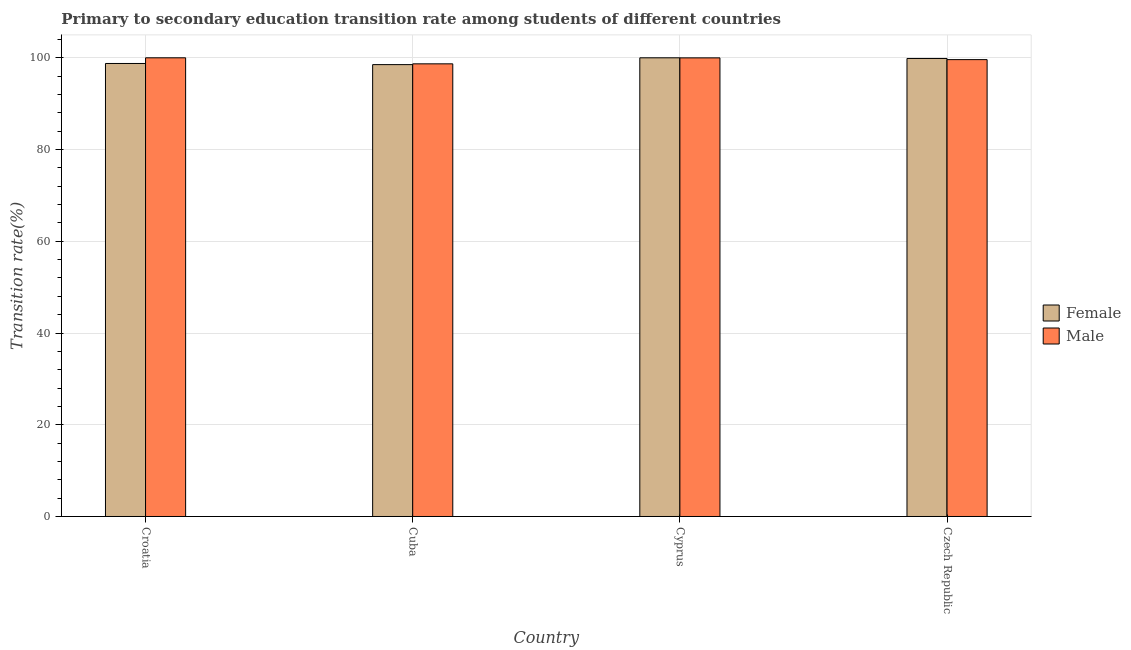How many groups of bars are there?
Your answer should be very brief. 4. Are the number of bars on each tick of the X-axis equal?
Give a very brief answer. Yes. How many bars are there on the 3rd tick from the left?
Your answer should be compact. 2. What is the label of the 3rd group of bars from the left?
Provide a short and direct response. Cyprus. What is the transition rate among female students in Cuba?
Offer a terse response. 98.52. Across all countries, what is the maximum transition rate among male students?
Make the answer very short. 100. Across all countries, what is the minimum transition rate among male students?
Your answer should be compact. 98.69. In which country was the transition rate among female students maximum?
Give a very brief answer. Cyprus. In which country was the transition rate among female students minimum?
Your answer should be compact. Cuba. What is the total transition rate among male students in the graph?
Provide a succinct answer. 398.28. What is the difference between the transition rate among male students in Croatia and that in Czech Republic?
Your answer should be compact. 0.39. What is the difference between the transition rate among male students in Croatia and the transition rate among female students in Czech Republic?
Your answer should be very brief. 0.15. What is the average transition rate among male students per country?
Your response must be concise. 99.57. What is the difference between the transition rate among male students and transition rate among female students in Cyprus?
Your answer should be compact. -0.01. In how many countries, is the transition rate among female students greater than 80 %?
Your response must be concise. 4. What is the ratio of the transition rate among male students in Croatia to that in Cyprus?
Give a very brief answer. 1. What is the difference between the highest and the second highest transition rate among female students?
Provide a short and direct response. 0.15. What is the difference between the highest and the lowest transition rate among female students?
Your answer should be very brief. 1.48. What does the 2nd bar from the left in Czech Republic represents?
Your response must be concise. Male. What does the 1st bar from the right in Cuba represents?
Your response must be concise. Male. How many bars are there?
Your answer should be very brief. 8. Are the values on the major ticks of Y-axis written in scientific E-notation?
Your answer should be compact. No. Does the graph contain any zero values?
Provide a short and direct response. No. What is the title of the graph?
Offer a terse response. Primary to secondary education transition rate among students of different countries. What is the label or title of the Y-axis?
Ensure brevity in your answer.  Transition rate(%). What is the Transition rate(%) in Female in Croatia?
Make the answer very short. 98.77. What is the Transition rate(%) of Male in Croatia?
Ensure brevity in your answer.  100. What is the Transition rate(%) of Female in Cuba?
Make the answer very short. 98.52. What is the Transition rate(%) of Male in Cuba?
Ensure brevity in your answer.  98.69. What is the Transition rate(%) in Male in Cyprus?
Provide a succinct answer. 99.99. What is the Transition rate(%) of Female in Czech Republic?
Your answer should be compact. 99.85. What is the Transition rate(%) in Male in Czech Republic?
Provide a short and direct response. 99.61. Across all countries, what is the maximum Transition rate(%) in Male?
Ensure brevity in your answer.  100. Across all countries, what is the minimum Transition rate(%) in Female?
Your answer should be very brief. 98.52. Across all countries, what is the minimum Transition rate(%) in Male?
Your answer should be compact. 98.69. What is the total Transition rate(%) of Female in the graph?
Keep it short and to the point. 397.13. What is the total Transition rate(%) in Male in the graph?
Provide a succinct answer. 398.28. What is the difference between the Transition rate(%) in Female in Croatia and that in Cuba?
Keep it short and to the point. 0.25. What is the difference between the Transition rate(%) of Male in Croatia and that in Cuba?
Give a very brief answer. 1.31. What is the difference between the Transition rate(%) of Female in Croatia and that in Cyprus?
Keep it short and to the point. -1.24. What is the difference between the Transition rate(%) of Male in Croatia and that in Cyprus?
Offer a very short reply. 0.01. What is the difference between the Transition rate(%) in Female in Croatia and that in Czech Republic?
Make the answer very short. -1.09. What is the difference between the Transition rate(%) of Male in Croatia and that in Czech Republic?
Make the answer very short. 0.39. What is the difference between the Transition rate(%) in Female in Cuba and that in Cyprus?
Make the answer very short. -1.48. What is the difference between the Transition rate(%) in Male in Cuba and that in Cyprus?
Your response must be concise. -1.3. What is the difference between the Transition rate(%) in Female in Cuba and that in Czech Republic?
Make the answer very short. -1.34. What is the difference between the Transition rate(%) in Male in Cuba and that in Czech Republic?
Provide a succinct answer. -0.92. What is the difference between the Transition rate(%) in Female in Cyprus and that in Czech Republic?
Make the answer very short. 0.15. What is the difference between the Transition rate(%) in Male in Cyprus and that in Czech Republic?
Your answer should be very brief. 0.38. What is the difference between the Transition rate(%) of Female in Croatia and the Transition rate(%) of Male in Cuba?
Provide a short and direct response. 0.08. What is the difference between the Transition rate(%) in Female in Croatia and the Transition rate(%) in Male in Cyprus?
Offer a very short reply. -1.22. What is the difference between the Transition rate(%) in Female in Croatia and the Transition rate(%) in Male in Czech Republic?
Provide a short and direct response. -0.84. What is the difference between the Transition rate(%) of Female in Cuba and the Transition rate(%) of Male in Cyprus?
Provide a short and direct response. -1.47. What is the difference between the Transition rate(%) of Female in Cuba and the Transition rate(%) of Male in Czech Republic?
Ensure brevity in your answer.  -1.09. What is the difference between the Transition rate(%) in Female in Cyprus and the Transition rate(%) in Male in Czech Republic?
Ensure brevity in your answer.  0.39. What is the average Transition rate(%) of Female per country?
Provide a succinct answer. 99.28. What is the average Transition rate(%) of Male per country?
Offer a very short reply. 99.57. What is the difference between the Transition rate(%) of Female and Transition rate(%) of Male in Croatia?
Provide a short and direct response. -1.24. What is the difference between the Transition rate(%) in Female and Transition rate(%) in Male in Cuba?
Offer a terse response. -0.17. What is the difference between the Transition rate(%) of Female and Transition rate(%) of Male in Cyprus?
Make the answer very short. 0.01. What is the difference between the Transition rate(%) of Female and Transition rate(%) of Male in Czech Republic?
Provide a short and direct response. 0.25. What is the ratio of the Transition rate(%) of Male in Croatia to that in Cuba?
Your answer should be compact. 1.01. What is the ratio of the Transition rate(%) in Female in Cuba to that in Cyprus?
Ensure brevity in your answer.  0.99. What is the ratio of the Transition rate(%) in Female in Cuba to that in Czech Republic?
Give a very brief answer. 0.99. What is the difference between the highest and the second highest Transition rate(%) of Female?
Ensure brevity in your answer.  0.15. What is the difference between the highest and the second highest Transition rate(%) in Male?
Ensure brevity in your answer.  0.01. What is the difference between the highest and the lowest Transition rate(%) of Female?
Ensure brevity in your answer.  1.48. What is the difference between the highest and the lowest Transition rate(%) of Male?
Provide a succinct answer. 1.31. 